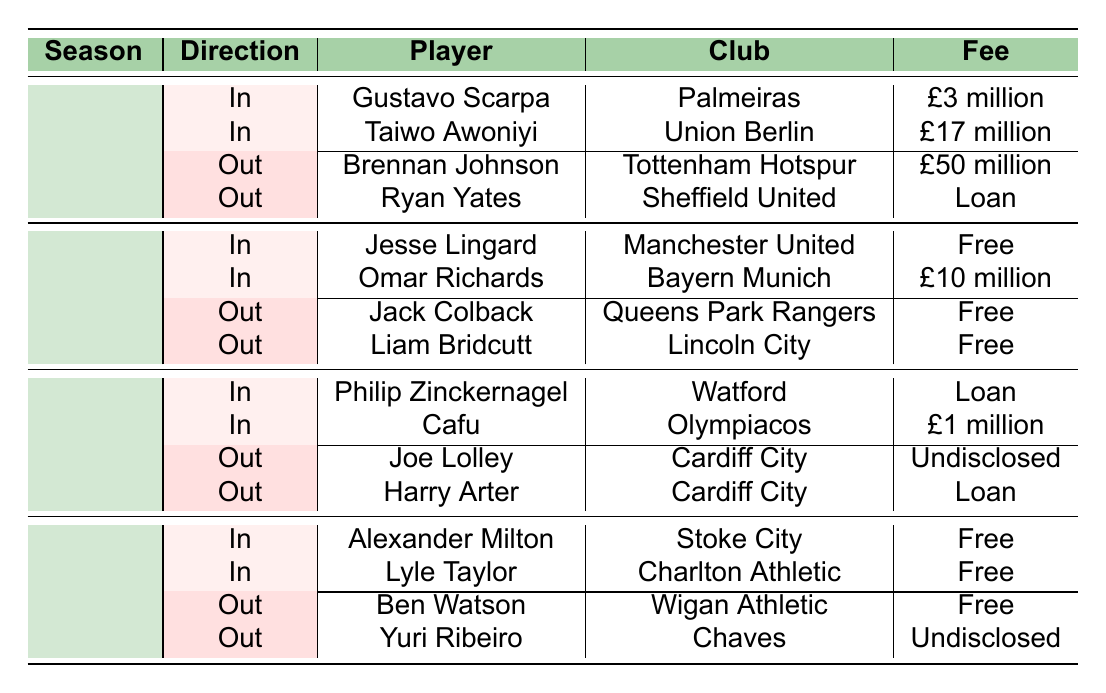What players did Nottingham Forest acquire in the 2023-24 season? The table shows two players acquired in the 2023-24 season: Gustavo Scarpa from Palmeiras and Taiwo Awoniyi from Union Berlin.
Answer: Gustavo Scarpa, Taiwo Awoniyi How many players were sold or loaned out in the 2022-23 season? In the 2022-23 season, there were two players who were sold or loaned out: Jack Colback and Liam Bridcutt.
Answer: 2 Which player had the highest transfer fee in the 2023-24 season? The table lists Brennan Johnson as going out for a fee of £50 million, which is the highest transfer fee mentioned in the 2023-24 season.
Answer: Brennan Johnson What was the total fee for players acquired by Nottingham Forest in the 2020-21 season? The fees for Alexander Milton and Lyle Taylor were both free, indicating that Nottingham Forest spent £0 to acquire these players in that season.
Answer: £0 Did Nottingham Forest receive any payment for Joe Lolley when he left for Cardiff City? According to the table, Joe Lolley was transferred to Cardiff City for an undisclosed fee, meaning it is not confirmed whether a payment was made or not.
Answer: No How many players did Nottingham Forest bring in during the 2021-22 season? The table indicates that Nottingham Forest brought in two players during the 2021-22 season: Philip Zinckernagel and Cafu.
Answer: 2 What percentage of the players acquired in the 2022-23 season were free transfers? Of the two players acquired in 2022-23, one (Jesse Lingard) was a free transfer. Thus, the percentage of free transfers is (1/2) * 100 = 50%.
Answer: 50% Who transferred to Sheffield United in the 2023-24 season? The table lists Ryan Yates as the player who transferred to Sheffield United in the 2023-24 season.
Answer: Ryan Yates Which position had the most incoming players in the 2021-22 season? In the 2021-22 season, there were two players acquired, one as a forward (Philip Zinckernagel) and one as a midfielder (Cafu), indicating an equal number; however, one was a forward and one was a midfielder. The position with the most incoming players is therefore tied between forward and midfielder.
Answer: Tie between Forward and Midfielder In which season was the highest transfer fee paid for an incoming player? The incoming players in the 2023-24 season had a total fee of £20 million (£3 million for Gustavo Scarpa and £17 million for Taiwo Awoniyi), making it the highest fee for incoming players in any season listed.
Answer: 2023-24 